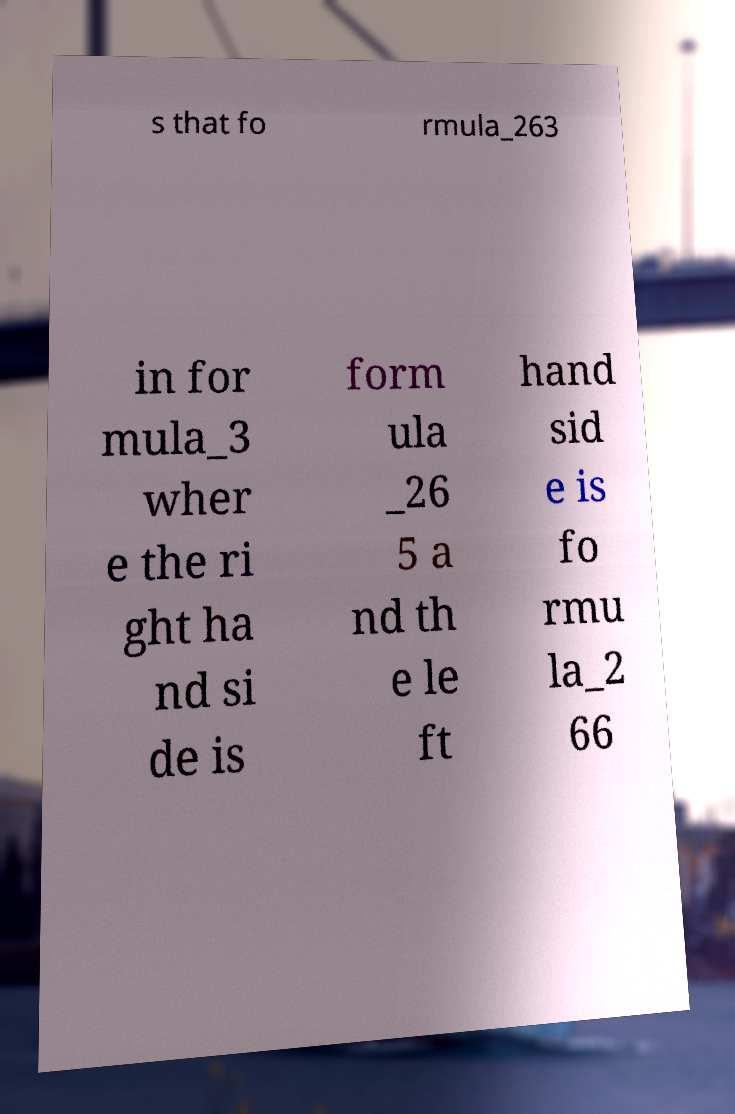Can you accurately transcribe the text from the provided image for me? s that fo rmula_263 in for mula_3 wher e the ri ght ha nd si de is form ula _26 5 a nd th e le ft hand sid e is fo rmu la_2 66 